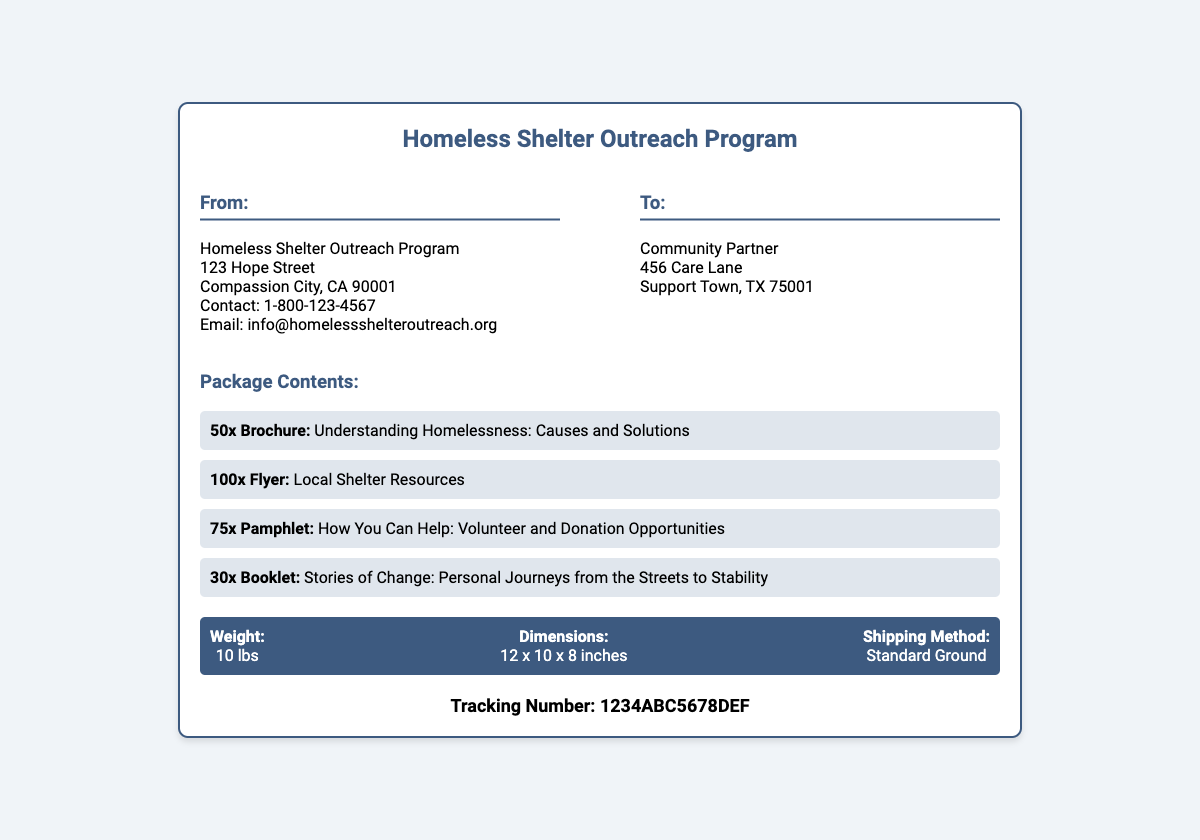What is the sender's contact number? The contact number of the sender is provided in the "From" section of the document.
Answer: 1-800-123-4567 What items are included in the package? The document lists the specific contents of the package under the "Package Contents" section.
Answer: Brochure, Flyer, Pamphlet, Booklet What is the total weight of the shipment? The weight of the shipment is specified in the "shipping details" section of the label.
Answer: 10 lbs What is the shipping method used for this package? The shipping method is explicitly mentioned in the "shipping details" section of the document.
Answer: Standard Ground What is the tracking number for this shipment? The tracking number is provided at the bottom of the document, clearly labeled.
Answer: 1234ABC5678DEF What is the recipient's address? The recipient's address is outlined in the "To" section of the document.
Answer: 456 Care Lane, Support Town, TX 75001 How many brochures were sent? The document specifies the quantity of brochures under "Package Contents."
Answer: 50x What is the dimension of the package? The package dimensions are listed in the "shipping details" section.
Answer: 12 x 10 x 8 inches 